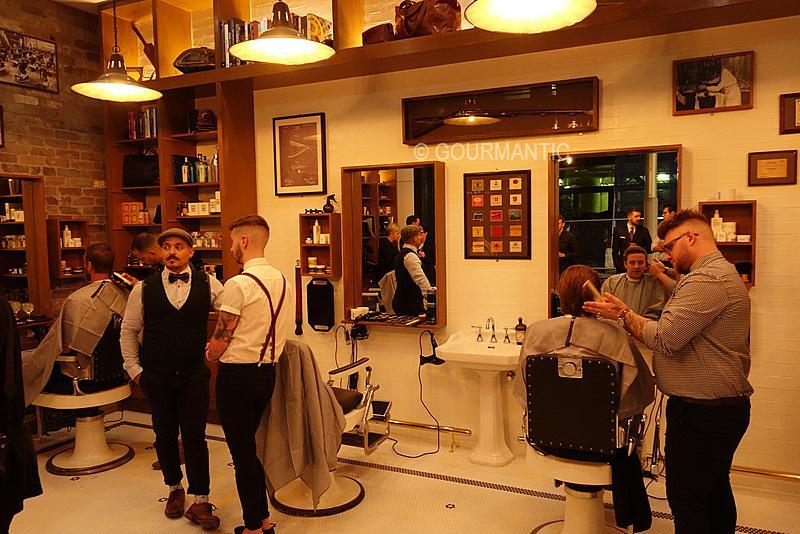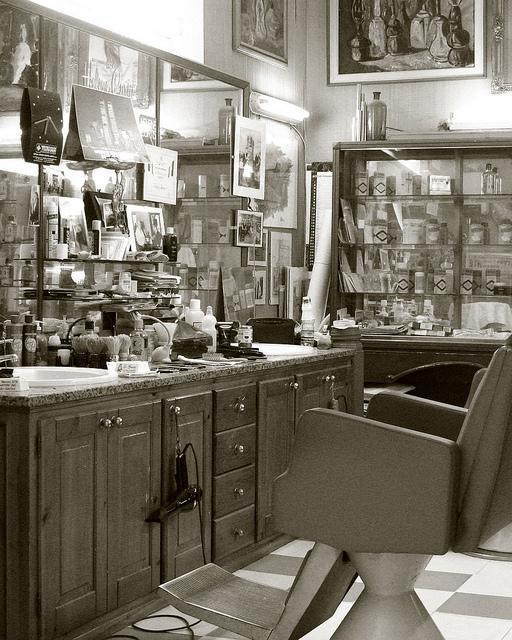The first image is the image on the left, the second image is the image on the right. Examine the images to the left and right. Is the description "The right image shows an empty barber chair turned leftward and facing a horizontal surface piled with items." accurate? Answer yes or no. Yes. 